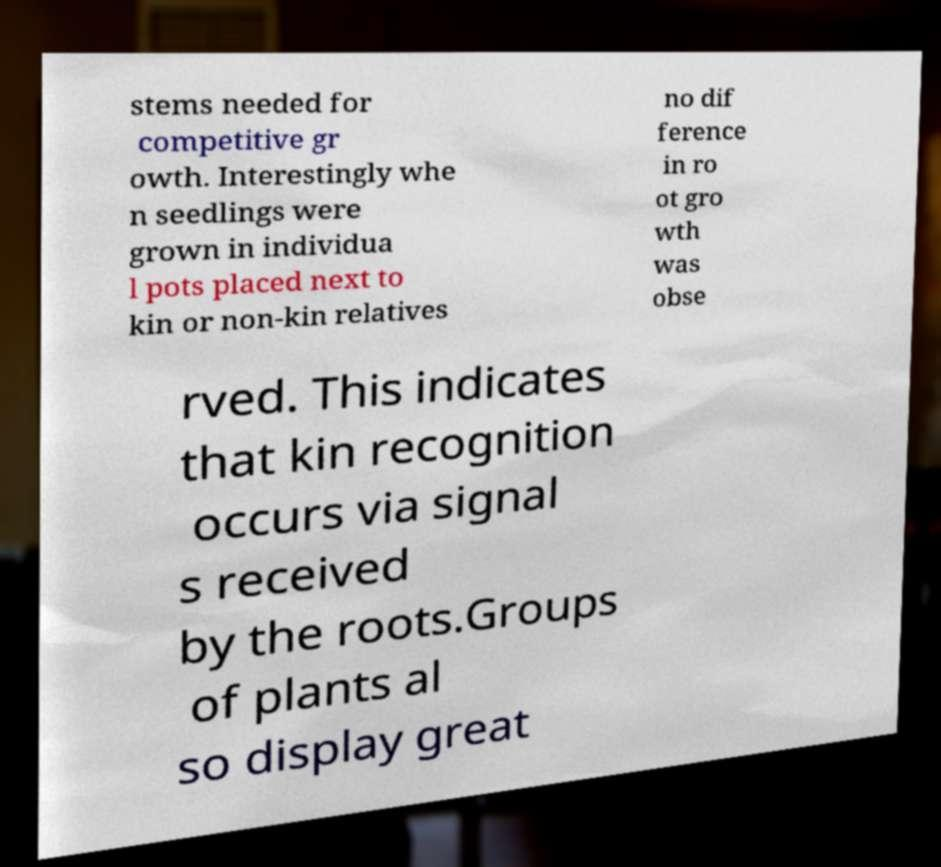There's text embedded in this image that I need extracted. Can you transcribe it verbatim? stems needed for competitive gr owth. Interestingly whe n seedlings were grown in individua l pots placed next to kin or non-kin relatives no dif ference in ro ot gro wth was obse rved. This indicates that kin recognition occurs via signal s received by the roots.Groups of plants al so display great 